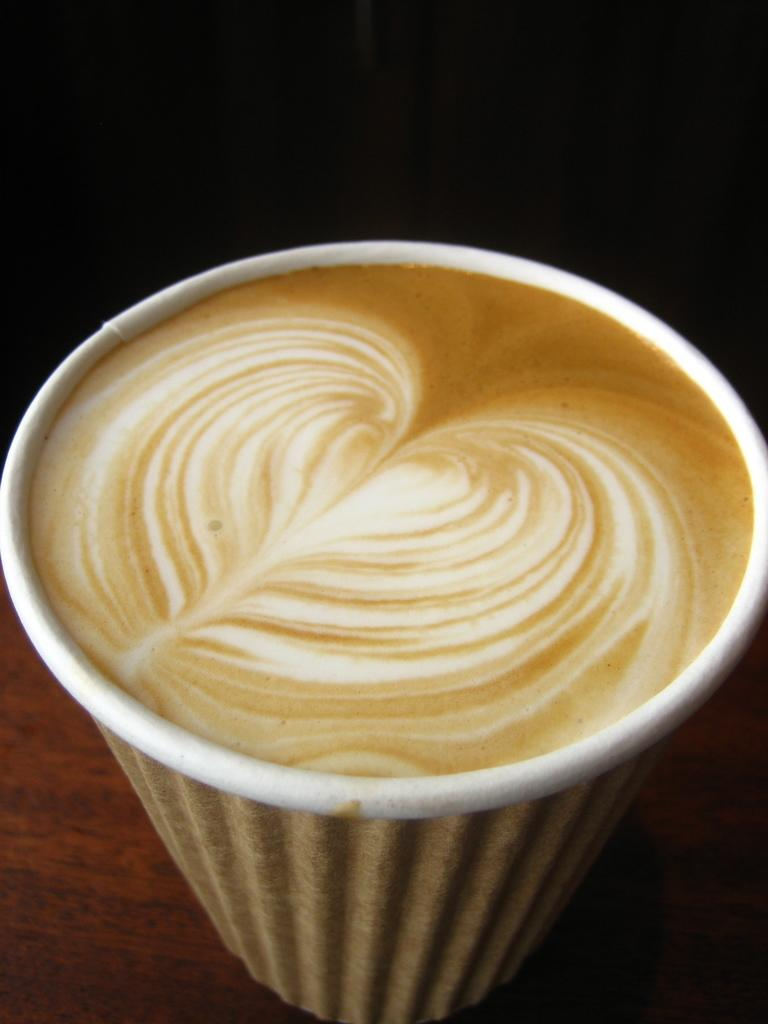What is in the image? There is a coffee cup in the image. What is inside the coffee cup? The coffee cup contains coffee. What type of duck is sitting on the coffee cup in the image? There is no duck present in the image; it only contains a coffee cup with coffee. 